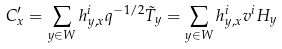Convert formula to latex. <formula><loc_0><loc_0><loc_500><loc_500>C ^ { \prime } _ { x } = \sum _ { y \in W } h ^ { i } _ { y , x } q ^ { - 1 / 2 } \tilde { T } _ { y } = \sum _ { y \in W } h ^ { i } _ { y , x } v ^ { i } H _ { y }</formula> 